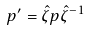<formula> <loc_0><loc_0><loc_500><loc_500>p ^ { \prime } = \hat { \zeta } p \hat { \zeta } ^ { - 1 }</formula> 